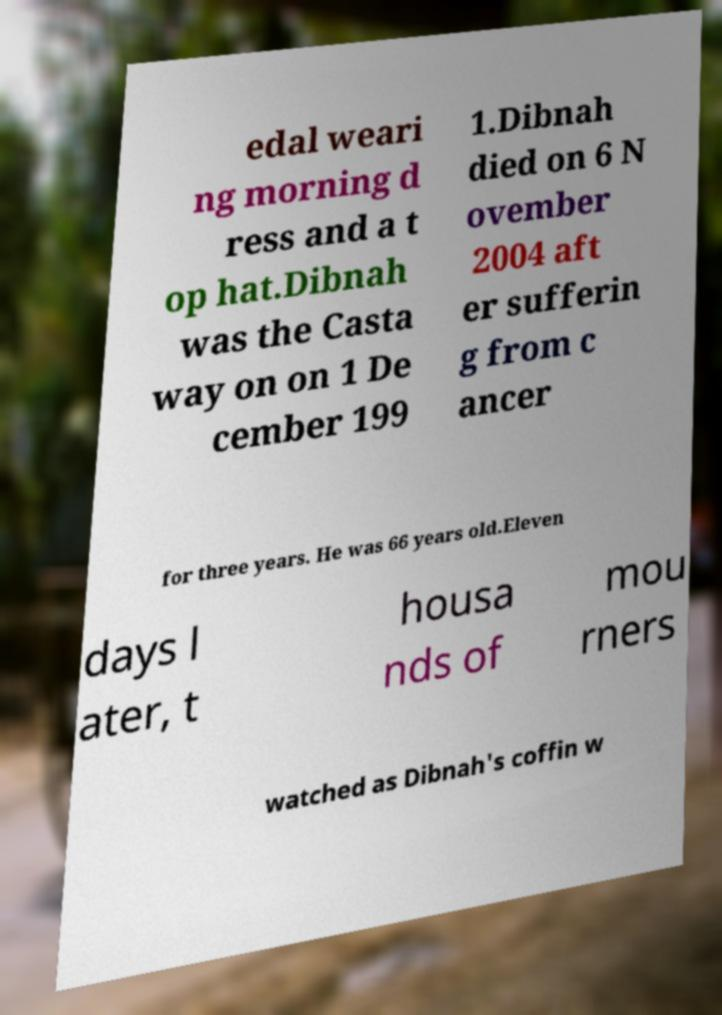Please identify and transcribe the text found in this image. edal weari ng morning d ress and a t op hat.Dibnah was the Casta way on on 1 De cember 199 1.Dibnah died on 6 N ovember 2004 aft er sufferin g from c ancer for three years. He was 66 years old.Eleven days l ater, t housa nds of mou rners watched as Dibnah's coffin w 